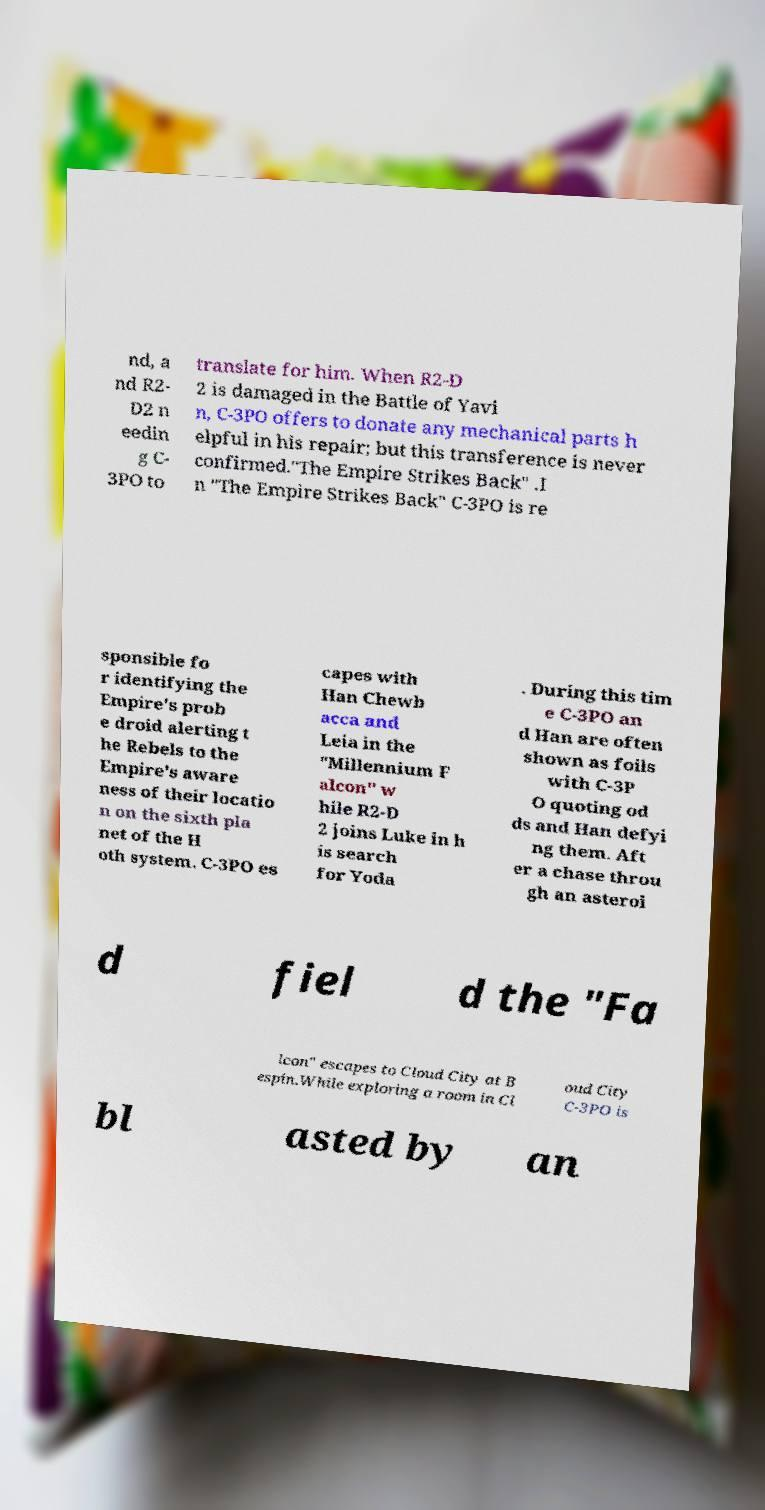Could you extract and type out the text from this image? nd, a nd R2- D2 n eedin g C- 3PO to translate for him. When R2-D 2 is damaged in the Battle of Yavi n, C-3PO offers to donate any mechanical parts h elpful in his repair; but this transference is never confirmed."The Empire Strikes Back" .I n "The Empire Strikes Back" C-3PO is re sponsible fo r identifying the Empire's prob e droid alerting t he Rebels to the Empire's aware ness of their locatio n on the sixth pla net of the H oth system. C-3PO es capes with Han Chewb acca and Leia in the "Millennium F alcon" w hile R2-D 2 joins Luke in h is search for Yoda . During this tim e C-3PO an d Han are often shown as foils with C-3P O quoting od ds and Han defyi ng them. Aft er a chase throu gh an asteroi d fiel d the "Fa lcon" escapes to Cloud City at B espin.While exploring a room in Cl oud City C-3PO is bl asted by an 